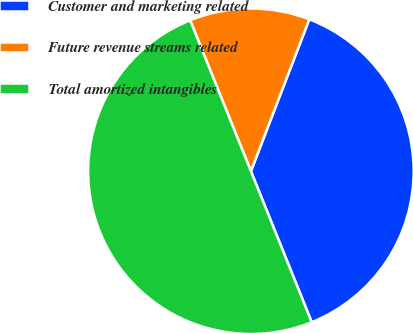Convert chart. <chart><loc_0><loc_0><loc_500><loc_500><pie_chart><fcel>Customer and marketing related<fcel>Future revenue streams related<fcel>Total amortized intangibles<nl><fcel>38.07%<fcel>11.93%<fcel>50.0%<nl></chart> 